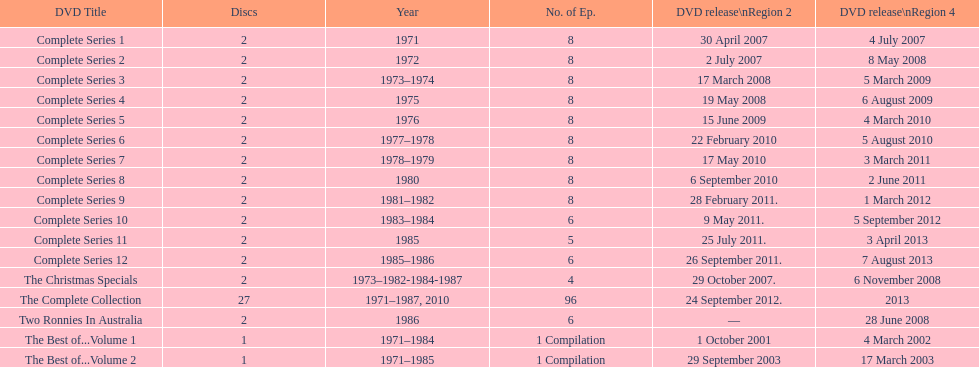Dvd containing less than 5 episodes The Christmas Specials. 